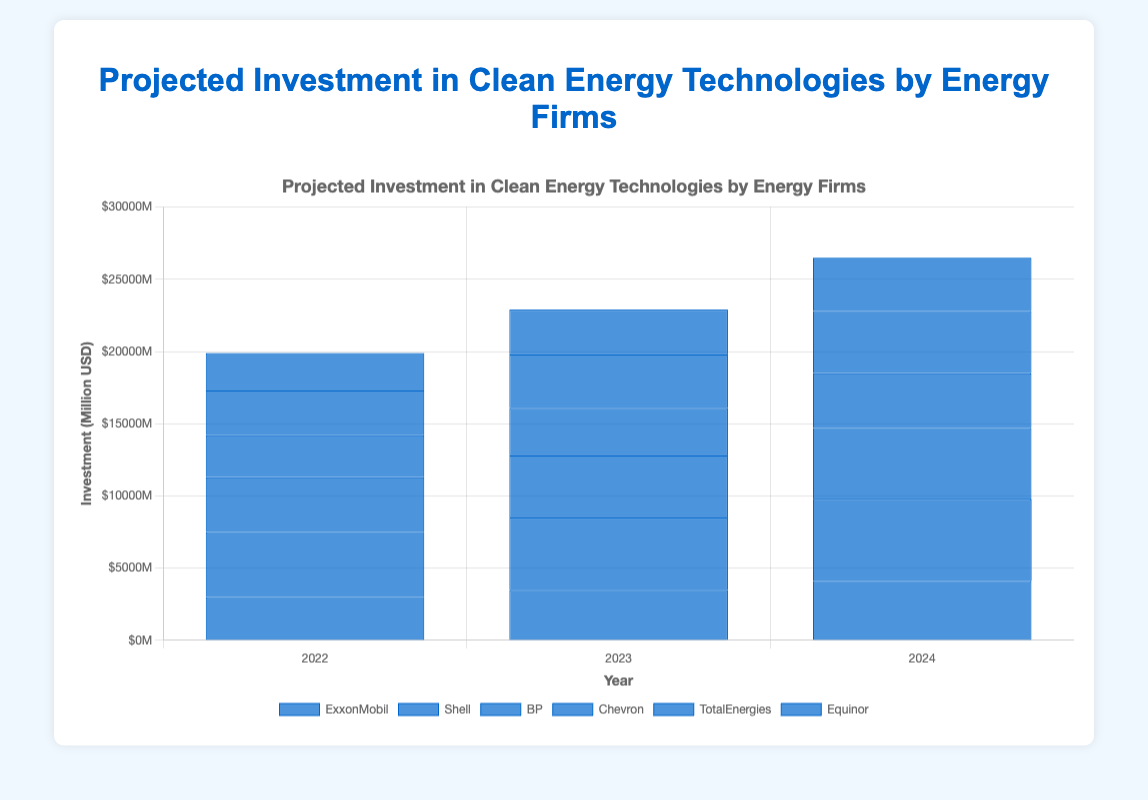What is the projected investment in clean energy by ExxonMobil in 2024? Locate the bar representing ExxonMobil in 2024 and read the value from the y-axis.
Answer: 4100 Which company has the highest projected investment in 2022? Compare the height of the bars for different companies in the year 2022.
Answer: Shell How much more is Shell projected to invest in 2024 compared to 2022? Subtract the investment amount of Shell in 2022 from the investment amount in 2024: 5700 - 4500 = 1200.
Answer: 1200 What is the total projected investment in clean energy for BP over the years 2022 to 2024? Add the investment amounts for BP over the three years: 3800 + 4300 + 4900 = 13000.
Answer: 13000 Which company has the lowest projected investment in 2023? Compare the height of the bars for different companies in the year 2023.
Answer: Equinor What is the average projected investment in clean energy for Chevron across the three years? Add the investment amounts for Chevron from 2022 to 2024 and divide by 3: (2900 + 3300 + 3800) / 3 = 3333.33.
Answer: 3333.33 Between which two consecutive years is the projected increase in investment for TotalEnergies the highest? Calculate the increase for each pair of consecutive years: 
2023-2022: 3700 - 3100 = 600,
2024-2023: 4300 - 3700 = 600. Both increases are equal, so either pair can be considered.
Answer: 2023-2024 or 2022-2023 What is the combined projected investment by Shell and BP in 2022? Add the investment amounts for Shell and BP in 2022: 4500 + 3800 = 8300.
Answer: 8300 Which company shows the highest growth in projected investment from 2022 to 2024? Calculate the growth for each company between 2022 and 2024, then identify the highest:
ExxonMobil: 4100 - 3000 = 1100,
Shell: 5700 - 4500 = 1200,
BP: 4900 - 3800 = 1100,
Chevron: 3800 - 2900 = 900,
TotalEnergies: 4300 - 3100 = 1200,
Equinor: 3700 - 2600 = 1100. Both Shell and TotalEnergies show the highest growth.
Answer: Shell and TotalEnergies 